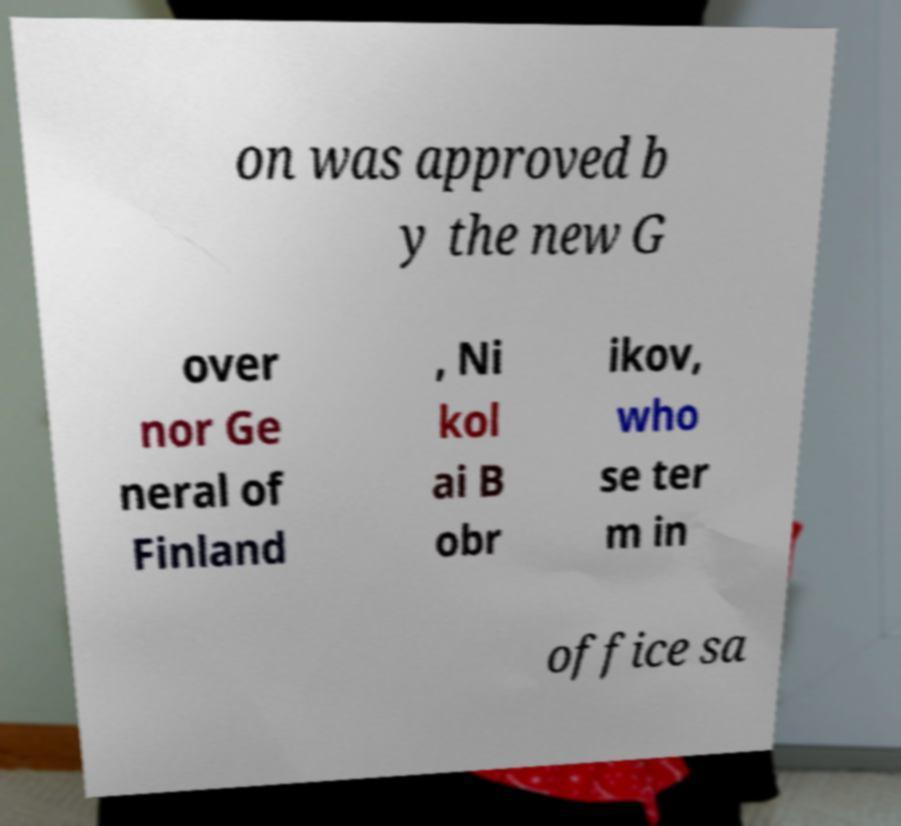There's text embedded in this image that I need extracted. Can you transcribe it verbatim? on was approved b y the new G over nor Ge neral of Finland , Ni kol ai B obr ikov, who se ter m in office sa 